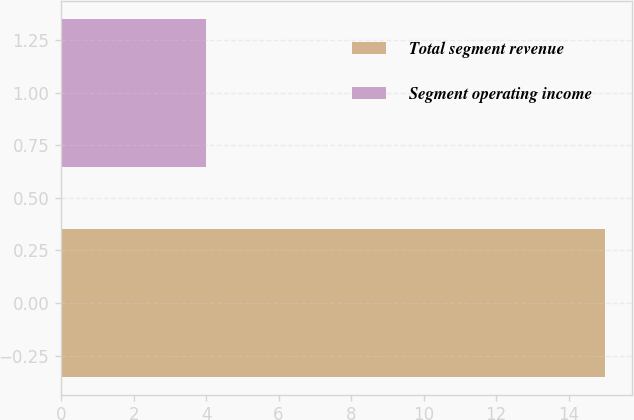Convert chart. <chart><loc_0><loc_0><loc_500><loc_500><bar_chart><fcel>Total segment revenue<fcel>Segment operating income<nl><fcel>15<fcel>4<nl></chart> 